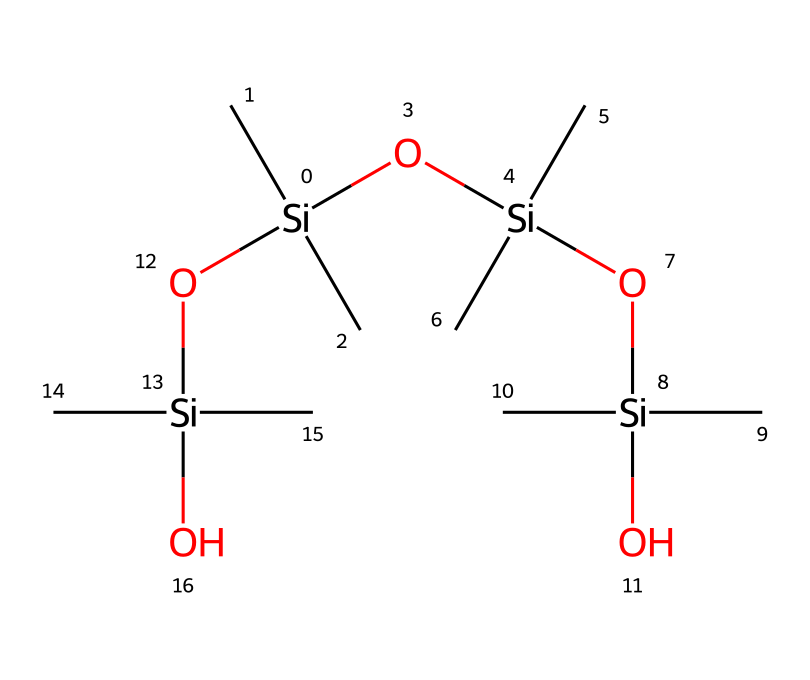What is the main element in this chemical structure? The chemical structure provided includes silicon atoms represented by [Si]. Since silicon is the central component of organosilicon compounds, it is the main element here.
Answer: silicon How many silicon atoms are in this chemical? By examining the SMILES notation, we can see there are four instances of [Si] which indicates there are four silicon atoms in total.
Answer: four What type of chemical is indicated by the multiple silicon-oxygen bonds? The presence of Si-O bonds is characteristic of siloxane compounds, which are a key feature of organosilicon compounds, indicating that this structure follows the siloxane chemistry.
Answer: siloxane What functional groups can be identified in this chemical? The chemical structure shows hydroxyl groups represented by O[Si], indicating that the functional groups are silanol (-Si-OH) groups, which are prevalent in silicone adhesives.
Answer: silanol What is the degree of branching in this chemical structure? The structure reveals that there are multiple silicon atoms connected through oxygen atoms, leading to a branched network, which is characteristic of silicones.
Answer: branched How many terminal hydroxyl groups are present in this chemical? By analyzing the structure, we see that there are four terminal links with -OH groups, indicating four terminal hydroxyl groups.
Answer: four What property does the presence of multiple siloxane linkages contribute to this chemical? The multiple siloxane linkages provide flexibility and thermal stability, which are essential properties for the performance of silicone adhesives in applications like stage equipment.
Answer: flexibility and thermal stability 